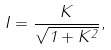Convert formula to latex. <formula><loc_0><loc_0><loc_500><loc_500>I = \frac { K } { \sqrt { 1 + K ^ { 2 } } } ,</formula> 